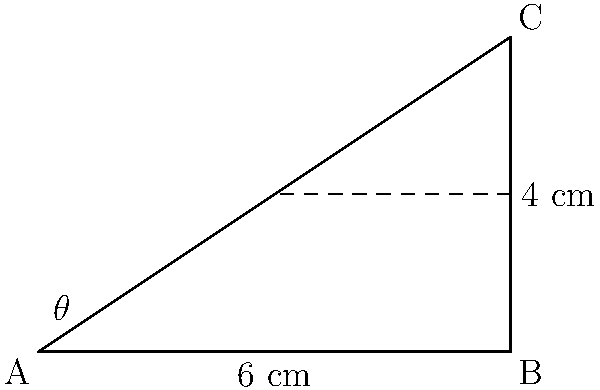In designing a pleated skirt inspired by traditional Indian sarees, you want to determine the angle at which the pleats should be folded. The skirt has a waist measurement of 6 cm and a pleat depth of 4 cm. If the pleats form a right-angled triangle as shown in the diagram, what is the angle $\theta$ of the pleat fold to the nearest degree? To find the angle $\theta$, we can use trigonometric ratios in the right-angled triangle:

1) In this triangle, we know:
   - The adjacent side (waist measurement) = 6 cm
   - The opposite side (pleat depth) = 4 cm

2) We can use the tangent ratio to find $\theta$:
   
   $\tan \theta = \frac{\text{opposite}}{\text{adjacent}} = \frac{4}{6}$

3) To find $\theta$, we need to use the inverse tangent (arctan) function:

   $\theta = \arctan(\frac{4}{6})$

4) Using a calculator or computer:

   $\theta = \arctan(0.6666...) \approx 33.69°$

5) Rounding to the nearest degree:

   $\theta \approx 34°$

Therefore, the angle at which the pleats should be folded is approximately 34°.
Answer: 34° 